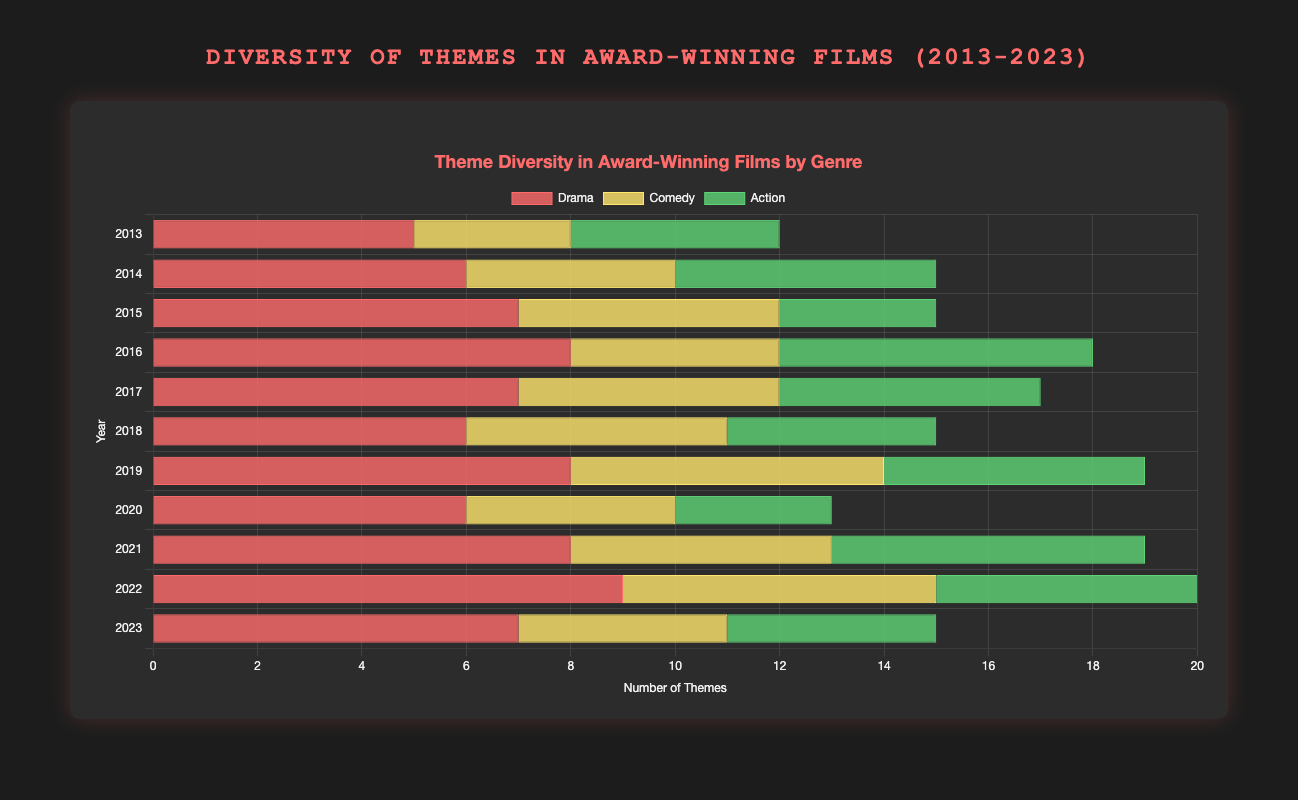Which year had the highest number of themes in Drama films? By looking at the horizontal bars representing the Drama genre across different years, the longest bar corresponds to the year 2022. Therefore, 2022 had the highest number of themes.
Answer: 2022 Compare the theme count in Action films between 2013 and 2022. Which year had a higher count? By comparing the length of the horizontal bars for Action films in 2013 and 2022, the bar for 2022 is longer. Therefore, 2022 had a higher theme count.
Answer: 2022 What is the difference in theme count between Comedy films in 2020 and Drama films in 2015? The Comedy genre in 2020 has 4 themes, and the Drama genre in 2015 has 7 themes. The difference in theme count is 7 - 4 = 3.
Answer: 3 Which genre had the highest theme count in 2016? By looking at the horizontal bars for the year 2016, the genre with the longest bar is Drama. Therefore, Drama had the highest theme count in 2016.
Answer: Drama In which years did the Comedy genre reach or exceed 5 themes? By observing the lengths of the horizontal bars for the Comedy genre, the years where Comedy reached or exceeded 5 themes are 2015, 2017, 2019, 2021, and 2022.
Answer: 2015, 2017, 2019, 2021, 2022 What's the average theme count of Action films over the entire decade? Summing the theme counts for Action films across all years: (4 + 5 + 3 + 6 + 5 + 4 + 5 + 3 + 6 + 5 + 4) = 50. There are 11 years, so the average is 50 / 11 ≈ 4.55.
Answer: 4.55 How does the theme diversity in Comedy films in 2013 compare to that in 2023? By comparing the horizontal bars for Comedy films in 2013 and 2023, we observe 3 themes in 2013 and 4 themes in 2023. Therefore, 2023 has 1 more theme than 2013.
Answer: 1 more theme in 2023 Identify the year with the greatest variation in theme count across all genres. To find the year with the greatest variation, compare the difference between the maximum and minimum theme counts for each year. The greatest variation is in 2022, with Drama having 9 themes and Action having 5 themes, resulting in a difference of 9 - 5 = 4.
Answer: 2022 In which year did Action films have the least number of themes, and how many were there? Observing the horizontal bars for Action across the years, the shortest bars are in 2015 and 2020, each with 3 themes. Thus, Action films had the least number of themes in these years.
Answer: 2015 and 2020, 3 themes 